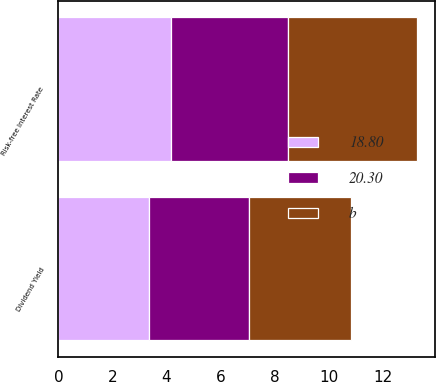Convert chart. <chart><loc_0><loc_0><loc_500><loc_500><stacked_bar_chart><ecel><fcel>Dividend Yield<fcel>Risk-free Interest Rate<nl><fcel>b<fcel>3.79<fcel>4.8<nl><fcel>20.30<fcel>3.7<fcel>4.32<nl><fcel>18.80<fcel>3.34<fcel>4.16<nl></chart> 